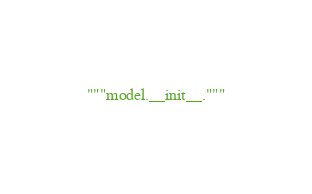Convert code to text. <code><loc_0><loc_0><loc_500><loc_500><_Python_>"""model.__init__."""</code> 